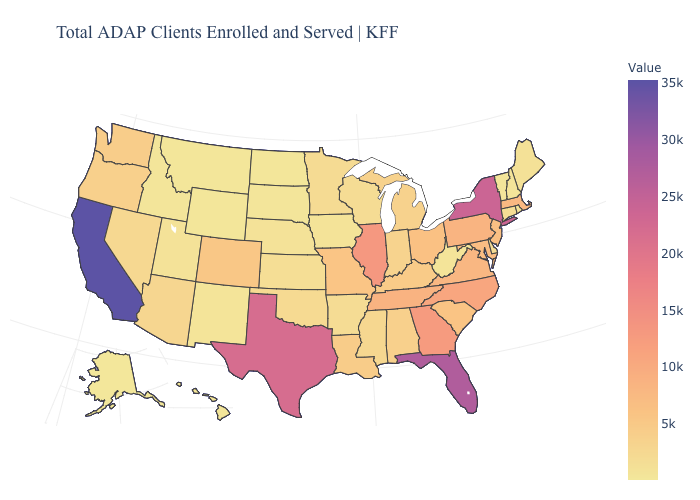Among the states that border Indiana , which have the highest value?
Keep it brief. Illinois. Does North Dakota have the lowest value in the MidWest?
Keep it brief. Yes. Does Louisiana have the lowest value in the USA?
Keep it brief. No. Among the states that border West Virginia , does Ohio have the lowest value?
Quick response, please. No. Does North Dakota have the lowest value in the MidWest?
Give a very brief answer. Yes. Which states have the lowest value in the USA?
Answer briefly. Alaska. 